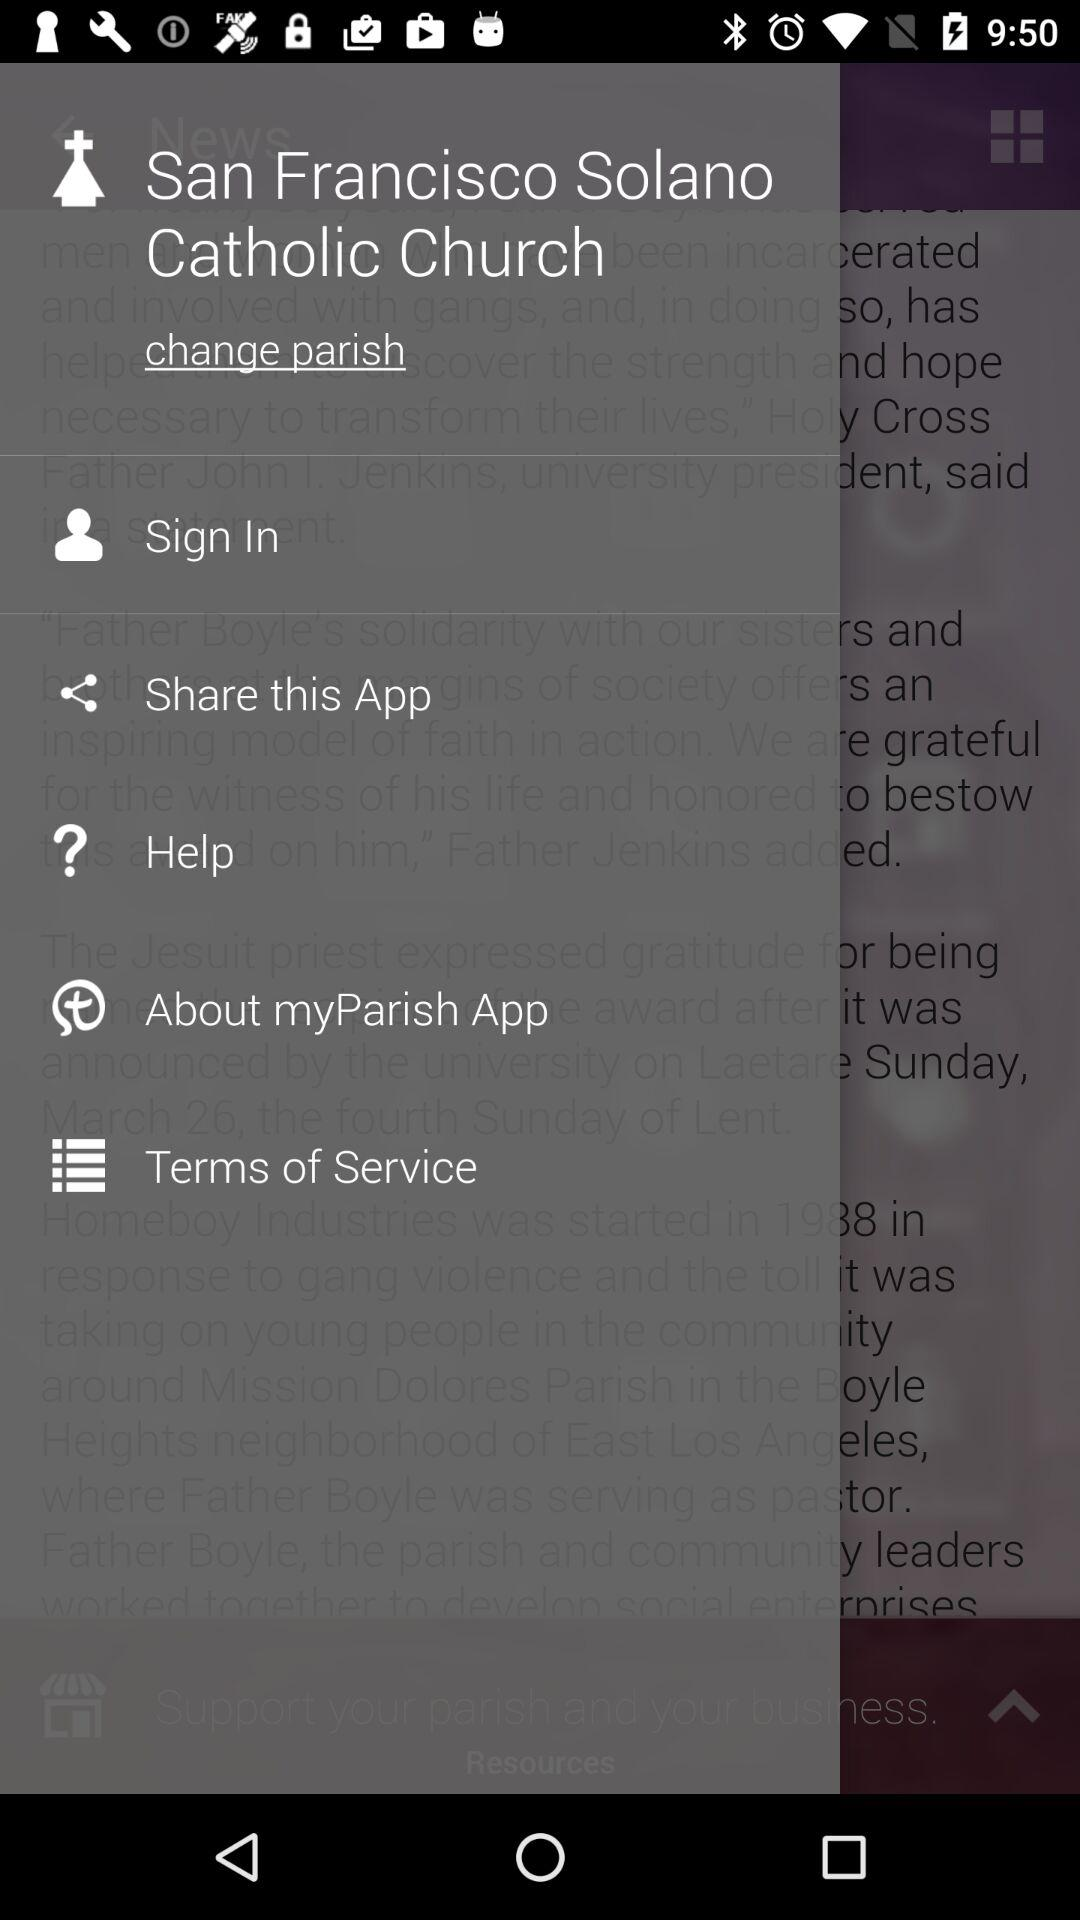What is the location of the church?
When the provided information is insufficient, respond with <no answer>. <no answer> 